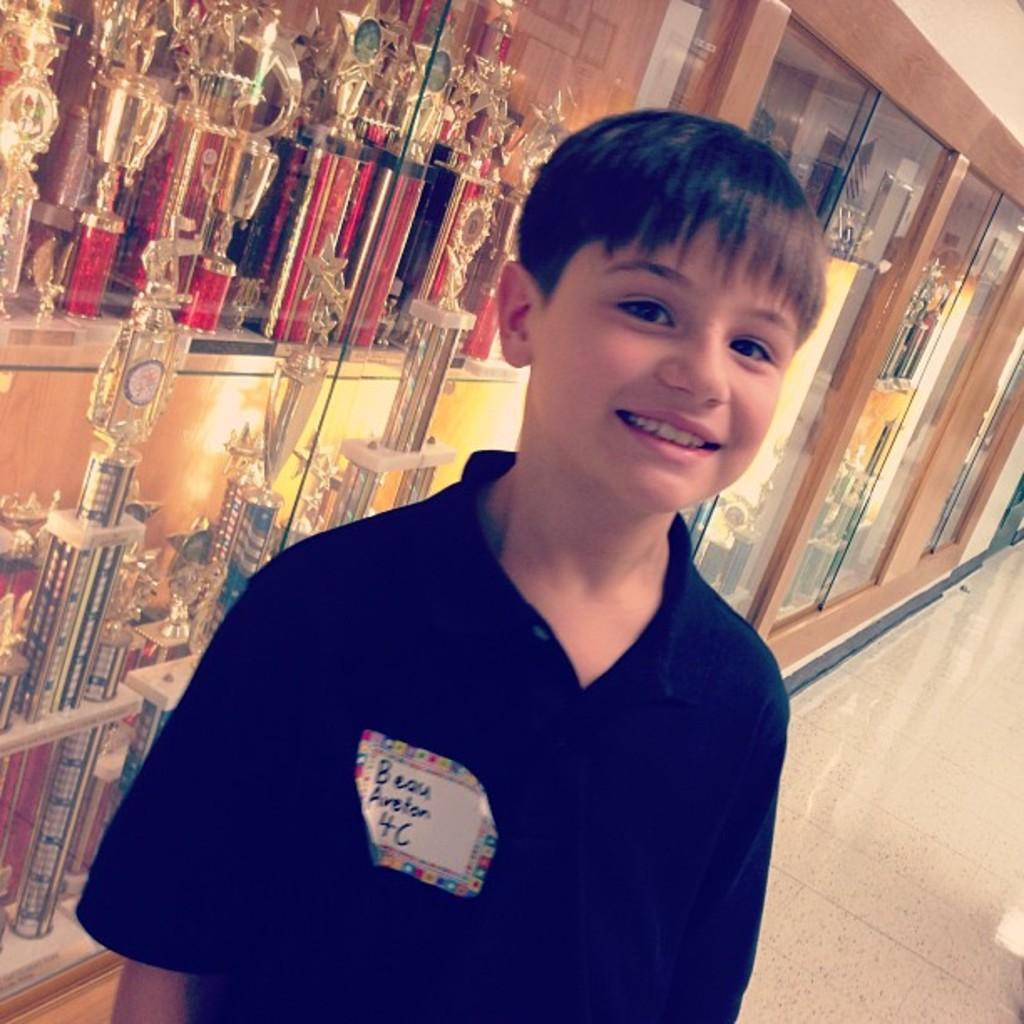Where was the image taken? The image was taken in a building. What is the main subject in the foreground of the image? There is a boy in the foreground of the image. What is the boy wearing? The boy is wearing a blue t-shirt. What can be seen in the background of the image? There are awards and prizes in cupboards in the background. What part of the floor is visible in the image? The floor is visible on the right side of the image. What angle did the boy use to make the discovery in the image? There is no indication of a discovery in the image, and the angle at which the boy is standing is not mentioned. 